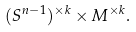<formula> <loc_0><loc_0><loc_500><loc_500>( S ^ { n - 1 } ) ^ { \times k } \times M ^ { \times k } .</formula> 